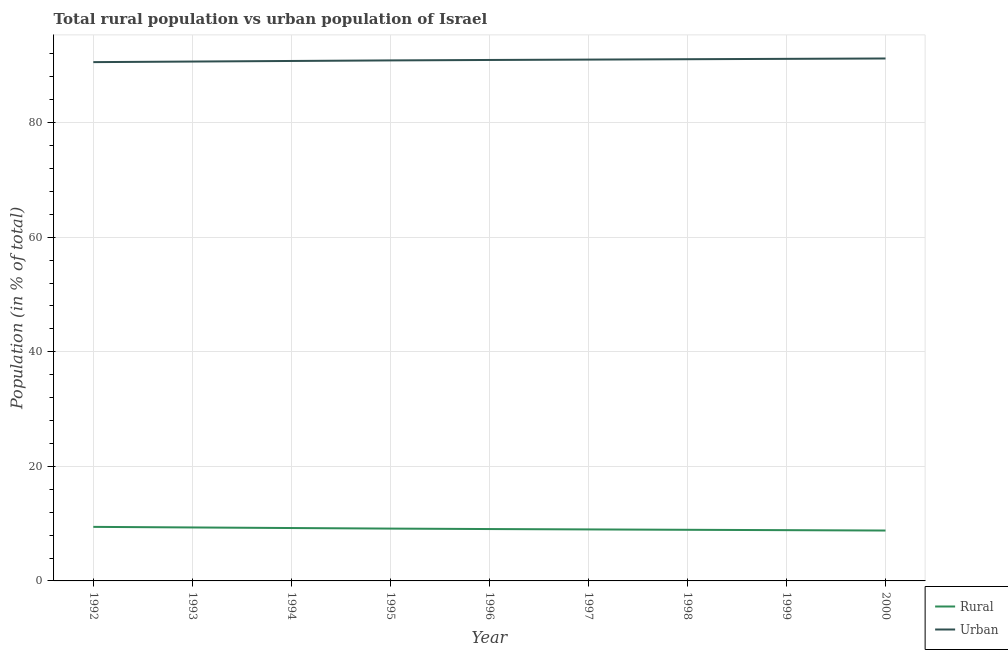Does the line corresponding to urban population intersect with the line corresponding to rural population?
Give a very brief answer. No. What is the rural population in 1999?
Keep it short and to the point. 8.86. Across all years, what is the maximum urban population?
Provide a short and direct response. 91.2. Across all years, what is the minimum urban population?
Provide a short and direct response. 90.56. In which year was the urban population minimum?
Your response must be concise. 1992. What is the total urban population in the graph?
Your response must be concise. 818.23. What is the difference between the rural population in 1994 and that in 2000?
Offer a terse response. 0.44. What is the difference between the urban population in 1999 and the rural population in 1994?
Offer a very short reply. 81.91. What is the average rural population per year?
Give a very brief answer. 9.09. In the year 1993, what is the difference between the rural population and urban population?
Offer a very short reply. -81.33. What is the ratio of the rural population in 1996 to that in 1997?
Make the answer very short. 1.01. Is the urban population in 1997 less than that in 1998?
Your response must be concise. Yes. Is the difference between the urban population in 1992 and 1997 greater than the difference between the rural population in 1992 and 1997?
Provide a short and direct response. No. What is the difference between the highest and the second highest urban population?
Offer a terse response. 0.06. What is the difference between the highest and the lowest urban population?
Provide a short and direct response. 0.64. Is the sum of the rural population in 1995 and 1996 greater than the maximum urban population across all years?
Make the answer very short. No. Is the urban population strictly less than the rural population over the years?
Your answer should be very brief. No. How many lines are there?
Your response must be concise. 2. What is the difference between two consecutive major ticks on the Y-axis?
Provide a succinct answer. 20. Does the graph contain grids?
Keep it short and to the point. Yes. How many legend labels are there?
Keep it short and to the point. 2. What is the title of the graph?
Offer a very short reply. Total rural population vs urban population of Israel. What is the label or title of the X-axis?
Provide a short and direct response. Year. What is the label or title of the Y-axis?
Provide a succinct answer. Population (in % of total). What is the Population (in % of total) in Rural in 1992?
Offer a very short reply. 9.44. What is the Population (in % of total) in Urban in 1992?
Your response must be concise. 90.56. What is the Population (in % of total) of Rural in 1993?
Give a very brief answer. 9.33. What is the Population (in % of total) of Urban in 1993?
Your answer should be very brief. 90.67. What is the Population (in % of total) in Rural in 1994?
Keep it short and to the point. 9.23. What is the Population (in % of total) in Urban in 1994?
Keep it short and to the point. 90.77. What is the Population (in % of total) of Rural in 1995?
Your response must be concise. 9.13. What is the Population (in % of total) of Urban in 1995?
Ensure brevity in your answer.  90.87. What is the Population (in % of total) in Rural in 1996?
Give a very brief answer. 9.06. What is the Population (in % of total) in Urban in 1996?
Ensure brevity in your answer.  90.94. What is the Population (in % of total) in Rural in 1997?
Give a very brief answer. 8.99. What is the Population (in % of total) of Urban in 1997?
Your answer should be very brief. 91.01. What is the Population (in % of total) of Rural in 1998?
Provide a succinct answer. 8.93. What is the Population (in % of total) in Urban in 1998?
Your answer should be compact. 91.07. What is the Population (in % of total) in Rural in 1999?
Offer a very short reply. 8.86. What is the Population (in % of total) of Urban in 1999?
Your answer should be very brief. 91.14. What is the Population (in % of total) in Rural in 2000?
Give a very brief answer. 8.8. What is the Population (in % of total) of Urban in 2000?
Give a very brief answer. 91.2. Across all years, what is the maximum Population (in % of total) in Rural?
Give a very brief answer. 9.44. Across all years, what is the maximum Population (in % of total) in Urban?
Your answer should be compact. 91.2. Across all years, what is the minimum Population (in % of total) of Rural?
Give a very brief answer. 8.8. Across all years, what is the minimum Population (in % of total) in Urban?
Provide a succinct answer. 90.56. What is the total Population (in % of total) in Rural in the graph?
Give a very brief answer. 81.77. What is the total Population (in % of total) in Urban in the graph?
Provide a succinct answer. 818.23. What is the difference between the Population (in % of total) of Rural in 1992 and that in 1993?
Your answer should be compact. 0.1. What is the difference between the Population (in % of total) of Urban in 1992 and that in 1993?
Offer a terse response. -0.1. What is the difference between the Population (in % of total) in Rural in 1992 and that in 1994?
Keep it short and to the point. 0.2. What is the difference between the Population (in % of total) of Urban in 1992 and that in 1994?
Provide a succinct answer. -0.2. What is the difference between the Population (in % of total) in Rural in 1992 and that in 1995?
Keep it short and to the point. 0.3. What is the difference between the Population (in % of total) in Urban in 1992 and that in 1995?
Make the answer very short. -0.3. What is the difference between the Population (in % of total) of Rural in 1992 and that in 1996?
Make the answer very short. 0.38. What is the difference between the Population (in % of total) in Urban in 1992 and that in 1996?
Ensure brevity in your answer.  -0.38. What is the difference between the Population (in % of total) of Rural in 1992 and that in 1997?
Ensure brevity in your answer.  0.44. What is the difference between the Population (in % of total) of Urban in 1992 and that in 1997?
Keep it short and to the point. -0.44. What is the difference between the Population (in % of total) of Rural in 1992 and that in 1998?
Make the answer very short. 0.51. What is the difference between the Population (in % of total) of Urban in 1992 and that in 1998?
Make the answer very short. -0.51. What is the difference between the Population (in % of total) in Rural in 1992 and that in 1999?
Keep it short and to the point. 0.57. What is the difference between the Population (in % of total) in Urban in 1992 and that in 1999?
Provide a succinct answer. -0.57. What is the difference between the Population (in % of total) in Rural in 1992 and that in 2000?
Your answer should be compact. 0.64. What is the difference between the Population (in % of total) in Urban in 1992 and that in 2000?
Offer a terse response. -0.64. What is the difference between the Population (in % of total) of Rural in 1993 and that in 1994?
Ensure brevity in your answer.  0.1. What is the difference between the Population (in % of total) in Urban in 1993 and that in 1994?
Keep it short and to the point. -0.1. What is the difference between the Population (in % of total) in Rural in 1993 and that in 1995?
Your answer should be compact. 0.2. What is the difference between the Population (in % of total) of Rural in 1993 and that in 1996?
Give a very brief answer. 0.28. What is the difference between the Population (in % of total) in Urban in 1993 and that in 1996?
Offer a terse response. -0.28. What is the difference between the Population (in % of total) of Rural in 1993 and that in 1997?
Offer a terse response. 0.34. What is the difference between the Population (in % of total) of Urban in 1993 and that in 1997?
Provide a succinct answer. -0.34. What is the difference between the Population (in % of total) in Rural in 1993 and that in 1998?
Make the answer very short. 0.41. What is the difference between the Population (in % of total) of Urban in 1993 and that in 1998?
Your answer should be compact. -0.41. What is the difference between the Population (in % of total) of Rural in 1993 and that in 1999?
Ensure brevity in your answer.  0.47. What is the difference between the Population (in % of total) of Urban in 1993 and that in 1999?
Ensure brevity in your answer.  -0.47. What is the difference between the Population (in % of total) in Rural in 1993 and that in 2000?
Keep it short and to the point. 0.54. What is the difference between the Population (in % of total) of Urban in 1993 and that in 2000?
Your response must be concise. -0.54. What is the difference between the Population (in % of total) in Rural in 1994 and that in 1995?
Provide a short and direct response. 0.1. What is the difference between the Population (in % of total) in Urban in 1994 and that in 1995?
Keep it short and to the point. -0.1. What is the difference between the Population (in % of total) of Rural in 1994 and that in 1996?
Your response must be concise. 0.18. What is the difference between the Population (in % of total) of Urban in 1994 and that in 1996?
Your answer should be compact. -0.18. What is the difference between the Population (in % of total) of Rural in 1994 and that in 1997?
Offer a terse response. 0.24. What is the difference between the Population (in % of total) of Urban in 1994 and that in 1997?
Your answer should be compact. -0.24. What is the difference between the Population (in % of total) of Rural in 1994 and that in 1998?
Offer a very short reply. 0.31. What is the difference between the Population (in % of total) in Urban in 1994 and that in 1998?
Keep it short and to the point. -0.31. What is the difference between the Population (in % of total) of Rural in 1994 and that in 1999?
Provide a succinct answer. 0.37. What is the difference between the Population (in % of total) in Urban in 1994 and that in 1999?
Your answer should be very brief. -0.37. What is the difference between the Population (in % of total) in Rural in 1994 and that in 2000?
Provide a short and direct response. 0.44. What is the difference between the Population (in % of total) in Urban in 1994 and that in 2000?
Give a very brief answer. -0.44. What is the difference between the Population (in % of total) of Rural in 1995 and that in 1996?
Provide a succinct answer. 0.08. What is the difference between the Population (in % of total) in Urban in 1995 and that in 1996?
Your answer should be compact. -0.08. What is the difference between the Population (in % of total) in Rural in 1995 and that in 1997?
Your response must be concise. 0.14. What is the difference between the Population (in % of total) of Urban in 1995 and that in 1997?
Provide a short and direct response. -0.14. What is the difference between the Population (in % of total) in Rural in 1995 and that in 1998?
Provide a short and direct response. 0.21. What is the difference between the Population (in % of total) of Urban in 1995 and that in 1998?
Your answer should be very brief. -0.21. What is the difference between the Population (in % of total) of Rural in 1995 and that in 1999?
Keep it short and to the point. 0.27. What is the difference between the Population (in % of total) of Urban in 1995 and that in 1999?
Give a very brief answer. -0.27. What is the difference between the Population (in % of total) in Rural in 1995 and that in 2000?
Your answer should be very brief. 0.34. What is the difference between the Population (in % of total) of Urban in 1995 and that in 2000?
Provide a succinct answer. -0.34. What is the difference between the Population (in % of total) of Rural in 1996 and that in 1997?
Offer a very short reply. 0.07. What is the difference between the Population (in % of total) in Urban in 1996 and that in 1997?
Your answer should be compact. -0.07. What is the difference between the Population (in % of total) in Rural in 1996 and that in 1998?
Provide a short and direct response. 0.13. What is the difference between the Population (in % of total) in Urban in 1996 and that in 1998?
Keep it short and to the point. -0.13. What is the difference between the Population (in % of total) of Rural in 1996 and that in 1999?
Your response must be concise. 0.2. What is the difference between the Population (in % of total) in Urban in 1996 and that in 1999?
Ensure brevity in your answer.  -0.2. What is the difference between the Population (in % of total) in Rural in 1996 and that in 2000?
Your answer should be compact. 0.26. What is the difference between the Population (in % of total) of Urban in 1996 and that in 2000?
Your response must be concise. -0.26. What is the difference between the Population (in % of total) of Rural in 1997 and that in 1998?
Make the answer very short. 0.07. What is the difference between the Population (in % of total) in Urban in 1997 and that in 1998?
Keep it short and to the point. -0.07. What is the difference between the Population (in % of total) in Rural in 1997 and that in 1999?
Ensure brevity in your answer.  0.13. What is the difference between the Population (in % of total) in Urban in 1997 and that in 1999?
Offer a terse response. -0.13. What is the difference between the Population (in % of total) of Rural in 1997 and that in 2000?
Your response must be concise. 0.19. What is the difference between the Population (in % of total) in Urban in 1997 and that in 2000?
Ensure brevity in your answer.  -0.19. What is the difference between the Population (in % of total) in Rural in 1998 and that in 1999?
Your response must be concise. 0.07. What is the difference between the Population (in % of total) of Urban in 1998 and that in 1999?
Make the answer very short. -0.07. What is the difference between the Population (in % of total) in Rural in 1998 and that in 2000?
Ensure brevity in your answer.  0.13. What is the difference between the Population (in % of total) in Urban in 1998 and that in 2000?
Offer a terse response. -0.13. What is the difference between the Population (in % of total) of Rural in 1999 and that in 2000?
Offer a very short reply. 0.06. What is the difference between the Population (in % of total) in Urban in 1999 and that in 2000?
Offer a terse response. -0.06. What is the difference between the Population (in % of total) in Rural in 1992 and the Population (in % of total) in Urban in 1993?
Your answer should be very brief. -81.23. What is the difference between the Population (in % of total) of Rural in 1992 and the Population (in % of total) of Urban in 1994?
Your answer should be very brief. -81.33. What is the difference between the Population (in % of total) in Rural in 1992 and the Population (in % of total) in Urban in 1995?
Offer a very short reply. -81.43. What is the difference between the Population (in % of total) of Rural in 1992 and the Population (in % of total) of Urban in 1996?
Provide a succinct answer. -81.51. What is the difference between the Population (in % of total) of Rural in 1992 and the Population (in % of total) of Urban in 1997?
Your answer should be very brief. -81.57. What is the difference between the Population (in % of total) of Rural in 1992 and the Population (in % of total) of Urban in 1998?
Offer a terse response. -81.64. What is the difference between the Population (in % of total) of Rural in 1992 and the Population (in % of total) of Urban in 1999?
Provide a succinct answer. -81.7. What is the difference between the Population (in % of total) of Rural in 1992 and the Population (in % of total) of Urban in 2000?
Ensure brevity in your answer.  -81.77. What is the difference between the Population (in % of total) in Rural in 1993 and the Population (in % of total) in Urban in 1994?
Ensure brevity in your answer.  -81.43. What is the difference between the Population (in % of total) of Rural in 1993 and the Population (in % of total) of Urban in 1995?
Your answer should be compact. -81.53. What is the difference between the Population (in % of total) in Rural in 1993 and the Population (in % of total) in Urban in 1996?
Make the answer very short. -81.61. What is the difference between the Population (in % of total) of Rural in 1993 and the Population (in % of total) of Urban in 1997?
Provide a short and direct response. -81.67. What is the difference between the Population (in % of total) in Rural in 1993 and the Population (in % of total) in Urban in 1998?
Offer a terse response. -81.74. What is the difference between the Population (in % of total) in Rural in 1993 and the Population (in % of total) in Urban in 1999?
Provide a short and direct response. -81.81. What is the difference between the Population (in % of total) in Rural in 1993 and the Population (in % of total) in Urban in 2000?
Offer a terse response. -81.87. What is the difference between the Population (in % of total) of Rural in 1994 and the Population (in % of total) of Urban in 1995?
Give a very brief answer. -81.63. What is the difference between the Population (in % of total) of Rural in 1994 and the Population (in % of total) of Urban in 1996?
Provide a succinct answer. -81.71. What is the difference between the Population (in % of total) in Rural in 1994 and the Population (in % of total) in Urban in 1997?
Ensure brevity in your answer.  -81.78. What is the difference between the Population (in % of total) of Rural in 1994 and the Population (in % of total) of Urban in 1998?
Offer a terse response. -81.84. What is the difference between the Population (in % of total) in Rural in 1994 and the Population (in % of total) in Urban in 1999?
Keep it short and to the point. -81.91. What is the difference between the Population (in % of total) of Rural in 1994 and the Population (in % of total) of Urban in 2000?
Your response must be concise. -81.97. What is the difference between the Population (in % of total) in Rural in 1995 and the Population (in % of total) in Urban in 1996?
Offer a terse response. -81.81. What is the difference between the Population (in % of total) of Rural in 1995 and the Population (in % of total) of Urban in 1997?
Your answer should be compact. -81.88. What is the difference between the Population (in % of total) in Rural in 1995 and the Population (in % of total) in Urban in 1998?
Provide a succinct answer. -81.94. What is the difference between the Population (in % of total) of Rural in 1995 and the Population (in % of total) of Urban in 1999?
Keep it short and to the point. -82. What is the difference between the Population (in % of total) in Rural in 1995 and the Population (in % of total) in Urban in 2000?
Provide a short and direct response. -82.07. What is the difference between the Population (in % of total) in Rural in 1996 and the Population (in % of total) in Urban in 1997?
Your answer should be very brief. -81.95. What is the difference between the Population (in % of total) of Rural in 1996 and the Population (in % of total) of Urban in 1998?
Ensure brevity in your answer.  -82.02. What is the difference between the Population (in % of total) of Rural in 1996 and the Population (in % of total) of Urban in 1999?
Your answer should be very brief. -82.08. What is the difference between the Population (in % of total) of Rural in 1996 and the Population (in % of total) of Urban in 2000?
Make the answer very short. -82.15. What is the difference between the Population (in % of total) of Rural in 1997 and the Population (in % of total) of Urban in 1998?
Your response must be concise. -82.08. What is the difference between the Population (in % of total) of Rural in 1997 and the Population (in % of total) of Urban in 1999?
Make the answer very short. -82.15. What is the difference between the Population (in % of total) of Rural in 1997 and the Population (in % of total) of Urban in 2000?
Provide a succinct answer. -82.21. What is the difference between the Population (in % of total) of Rural in 1998 and the Population (in % of total) of Urban in 1999?
Keep it short and to the point. -82.21. What is the difference between the Population (in % of total) of Rural in 1998 and the Population (in % of total) of Urban in 2000?
Your response must be concise. -82.28. What is the difference between the Population (in % of total) of Rural in 1999 and the Population (in % of total) of Urban in 2000?
Provide a succinct answer. -82.34. What is the average Population (in % of total) in Rural per year?
Provide a succinct answer. 9.09. What is the average Population (in % of total) of Urban per year?
Give a very brief answer. 90.91. In the year 1992, what is the difference between the Population (in % of total) in Rural and Population (in % of total) in Urban?
Make the answer very short. -81.13. In the year 1993, what is the difference between the Population (in % of total) in Rural and Population (in % of total) in Urban?
Ensure brevity in your answer.  -81.33. In the year 1994, what is the difference between the Population (in % of total) of Rural and Population (in % of total) of Urban?
Give a very brief answer. -81.53. In the year 1995, what is the difference between the Population (in % of total) in Rural and Population (in % of total) in Urban?
Offer a very short reply. -81.73. In the year 1996, what is the difference between the Population (in % of total) in Rural and Population (in % of total) in Urban?
Make the answer very short. -81.89. In the year 1997, what is the difference between the Population (in % of total) in Rural and Population (in % of total) in Urban?
Make the answer very short. -82.02. In the year 1998, what is the difference between the Population (in % of total) in Rural and Population (in % of total) in Urban?
Your response must be concise. -82.15. In the year 1999, what is the difference between the Population (in % of total) in Rural and Population (in % of total) in Urban?
Provide a succinct answer. -82.28. In the year 2000, what is the difference between the Population (in % of total) in Rural and Population (in % of total) in Urban?
Ensure brevity in your answer.  -82.41. What is the ratio of the Population (in % of total) of Rural in 1992 to that in 1993?
Offer a very short reply. 1.01. What is the ratio of the Population (in % of total) of Urban in 1992 to that in 1993?
Offer a terse response. 1. What is the ratio of the Population (in % of total) in Rural in 1992 to that in 1994?
Offer a terse response. 1.02. What is the ratio of the Population (in % of total) of Urban in 1992 to that in 1994?
Offer a very short reply. 1. What is the ratio of the Population (in % of total) in Rural in 1992 to that in 1995?
Your answer should be compact. 1.03. What is the ratio of the Population (in % of total) of Rural in 1992 to that in 1996?
Make the answer very short. 1.04. What is the ratio of the Population (in % of total) of Urban in 1992 to that in 1996?
Offer a very short reply. 1. What is the ratio of the Population (in % of total) of Rural in 1992 to that in 1997?
Offer a very short reply. 1.05. What is the ratio of the Population (in % of total) of Rural in 1992 to that in 1998?
Make the answer very short. 1.06. What is the ratio of the Population (in % of total) in Urban in 1992 to that in 1998?
Your answer should be compact. 0.99. What is the ratio of the Population (in % of total) in Rural in 1992 to that in 1999?
Offer a terse response. 1.06. What is the ratio of the Population (in % of total) of Rural in 1992 to that in 2000?
Give a very brief answer. 1.07. What is the ratio of the Population (in % of total) of Urban in 1992 to that in 2000?
Your answer should be compact. 0.99. What is the ratio of the Population (in % of total) in Rural in 1993 to that in 1994?
Offer a terse response. 1.01. What is the ratio of the Population (in % of total) in Rural in 1993 to that in 1995?
Provide a short and direct response. 1.02. What is the ratio of the Population (in % of total) of Urban in 1993 to that in 1995?
Your answer should be compact. 1. What is the ratio of the Population (in % of total) of Rural in 1993 to that in 1996?
Keep it short and to the point. 1.03. What is the ratio of the Population (in % of total) in Rural in 1993 to that in 1997?
Your answer should be compact. 1.04. What is the ratio of the Population (in % of total) in Urban in 1993 to that in 1997?
Provide a succinct answer. 1. What is the ratio of the Population (in % of total) of Rural in 1993 to that in 1998?
Ensure brevity in your answer.  1.05. What is the ratio of the Population (in % of total) of Urban in 1993 to that in 1998?
Give a very brief answer. 1. What is the ratio of the Population (in % of total) in Rural in 1993 to that in 1999?
Your answer should be compact. 1.05. What is the ratio of the Population (in % of total) in Rural in 1993 to that in 2000?
Ensure brevity in your answer.  1.06. What is the ratio of the Population (in % of total) in Rural in 1994 to that in 1995?
Ensure brevity in your answer.  1.01. What is the ratio of the Population (in % of total) in Urban in 1994 to that in 1995?
Offer a terse response. 1. What is the ratio of the Population (in % of total) in Rural in 1994 to that in 1996?
Make the answer very short. 1.02. What is the ratio of the Population (in % of total) in Urban in 1994 to that in 1996?
Your response must be concise. 1. What is the ratio of the Population (in % of total) in Rural in 1994 to that in 1997?
Provide a succinct answer. 1.03. What is the ratio of the Population (in % of total) in Rural in 1994 to that in 1998?
Offer a terse response. 1.03. What is the ratio of the Population (in % of total) in Rural in 1994 to that in 1999?
Provide a short and direct response. 1.04. What is the ratio of the Population (in % of total) in Urban in 1994 to that in 1999?
Your response must be concise. 1. What is the ratio of the Population (in % of total) in Rural in 1994 to that in 2000?
Provide a short and direct response. 1.05. What is the ratio of the Population (in % of total) in Urban in 1994 to that in 2000?
Provide a short and direct response. 1. What is the ratio of the Population (in % of total) in Rural in 1995 to that in 1996?
Keep it short and to the point. 1.01. What is the ratio of the Population (in % of total) in Urban in 1995 to that in 1996?
Ensure brevity in your answer.  1. What is the ratio of the Population (in % of total) in Rural in 1995 to that in 1997?
Your answer should be very brief. 1.02. What is the ratio of the Population (in % of total) in Urban in 1995 to that in 1997?
Provide a succinct answer. 1. What is the ratio of the Population (in % of total) of Rural in 1995 to that in 1998?
Ensure brevity in your answer.  1.02. What is the ratio of the Population (in % of total) of Rural in 1995 to that in 1999?
Provide a short and direct response. 1.03. What is the ratio of the Population (in % of total) in Urban in 1995 to that in 1999?
Your answer should be very brief. 1. What is the ratio of the Population (in % of total) in Rural in 1995 to that in 2000?
Provide a short and direct response. 1.04. What is the ratio of the Population (in % of total) in Rural in 1996 to that in 1997?
Give a very brief answer. 1.01. What is the ratio of the Population (in % of total) of Urban in 1996 to that in 1997?
Make the answer very short. 1. What is the ratio of the Population (in % of total) in Rural in 1996 to that in 1998?
Offer a terse response. 1.01. What is the ratio of the Population (in % of total) in Rural in 1996 to that in 1999?
Offer a very short reply. 1.02. What is the ratio of the Population (in % of total) in Urban in 1996 to that in 1999?
Make the answer very short. 1. What is the ratio of the Population (in % of total) of Rural in 1996 to that in 2000?
Your answer should be compact. 1.03. What is the ratio of the Population (in % of total) of Rural in 1997 to that in 1998?
Your answer should be very brief. 1.01. What is the ratio of the Population (in % of total) in Rural in 1997 to that in 1999?
Make the answer very short. 1.01. What is the ratio of the Population (in % of total) of Rural in 1997 to that in 2000?
Provide a succinct answer. 1.02. What is the ratio of the Population (in % of total) in Urban in 1997 to that in 2000?
Offer a very short reply. 1. What is the ratio of the Population (in % of total) in Rural in 1998 to that in 1999?
Your response must be concise. 1.01. What is the ratio of the Population (in % of total) in Rural in 1998 to that in 2000?
Provide a short and direct response. 1.01. What is the ratio of the Population (in % of total) in Urban in 1998 to that in 2000?
Ensure brevity in your answer.  1. What is the ratio of the Population (in % of total) in Rural in 1999 to that in 2000?
Ensure brevity in your answer.  1.01. What is the difference between the highest and the second highest Population (in % of total) in Rural?
Make the answer very short. 0.1. What is the difference between the highest and the second highest Population (in % of total) of Urban?
Give a very brief answer. 0.06. What is the difference between the highest and the lowest Population (in % of total) of Rural?
Offer a terse response. 0.64. What is the difference between the highest and the lowest Population (in % of total) in Urban?
Provide a short and direct response. 0.64. 